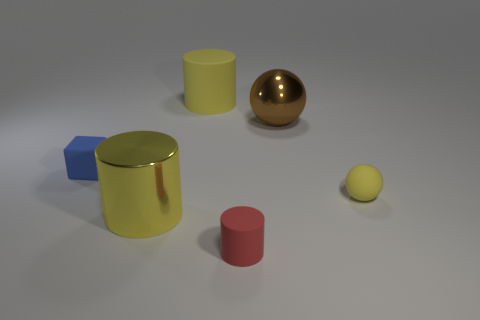What material is the tiny thing that is the same shape as the big brown thing?
Offer a terse response. Rubber. There is a matte object that is behind the small blue matte thing; does it have the same shape as the tiny matte object on the left side of the red rubber cylinder?
Offer a terse response. No. Is the number of cylinders behind the big brown object less than the number of yellow cylinders that are to the right of the red cylinder?
Your response must be concise. No. What number of other things are there of the same shape as the red matte object?
Your answer should be compact. 2. There is a blue object that is the same material as the tiny yellow sphere; what shape is it?
Offer a very short reply. Cube. There is a matte object that is in front of the tiny matte block and behind the red matte cylinder; what color is it?
Offer a terse response. Yellow. Do the large yellow object behind the large metallic cylinder and the tiny blue object have the same material?
Give a very brief answer. Yes. Is the number of big shiny spheres in front of the large metal cylinder less than the number of small cyan rubber objects?
Offer a terse response. No. Are there any other cylinders that have the same material as the red cylinder?
Make the answer very short. Yes. There is a red rubber object; is it the same size as the rubber cylinder that is behind the blue rubber cube?
Offer a very short reply. No. 